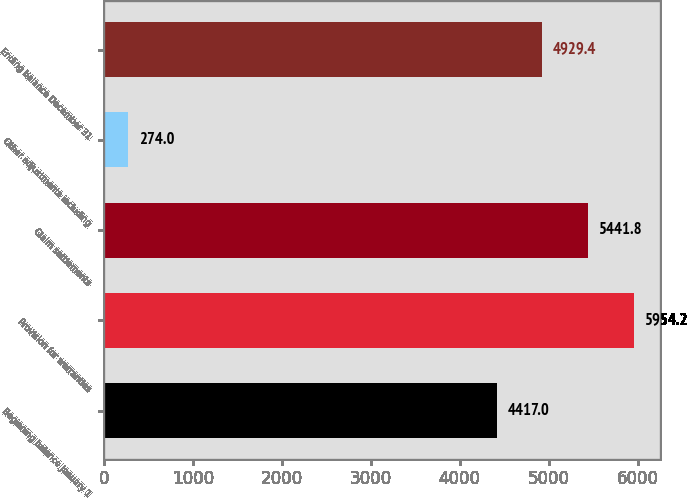Convert chart. <chart><loc_0><loc_0><loc_500><loc_500><bar_chart><fcel>Beginning balance January 1<fcel>Provision for warranties<fcel>Claim settlements<fcel>Other adjustments including<fcel>Ending balance December 31<nl><fcel>4417<fcel>5954.2<fcel>5441.8<fcel>274<fcel>4929.4<nl></chart> 